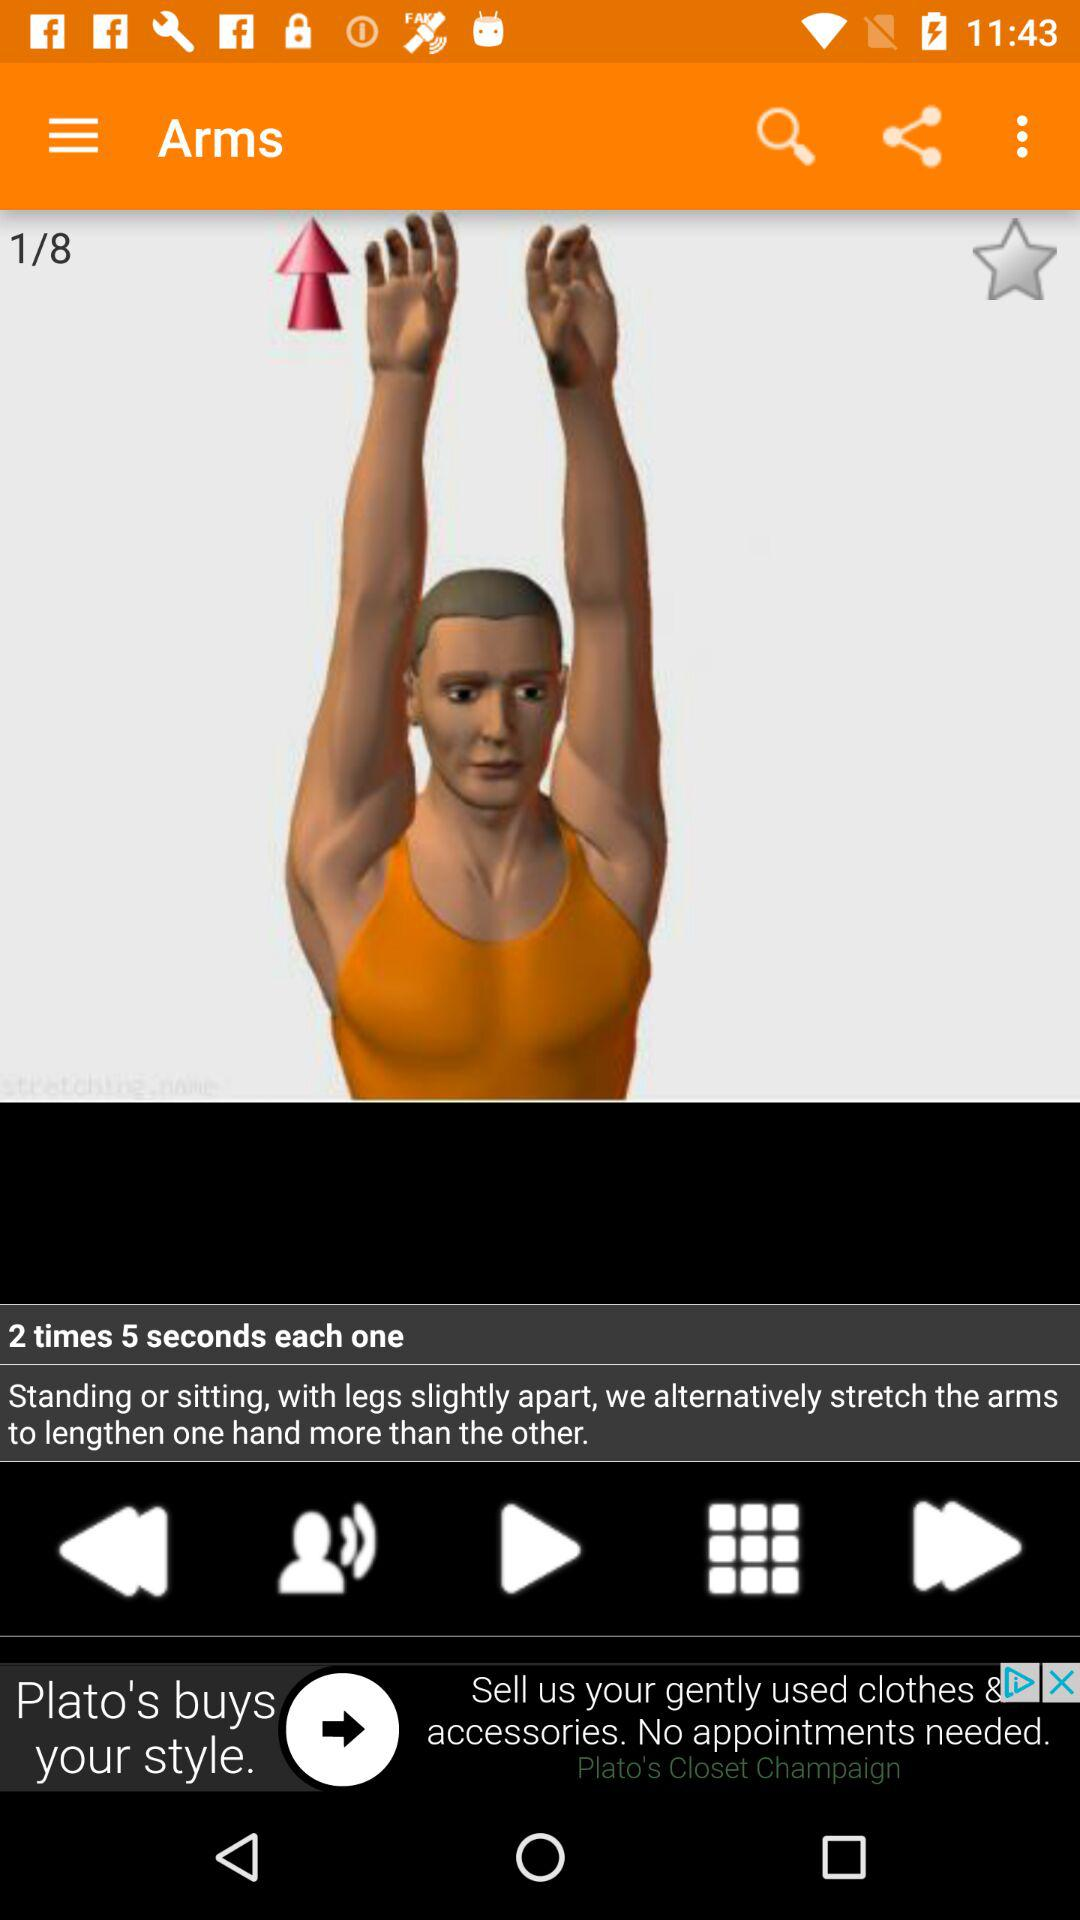How many repetitions are there? There are 2 repetitions. 